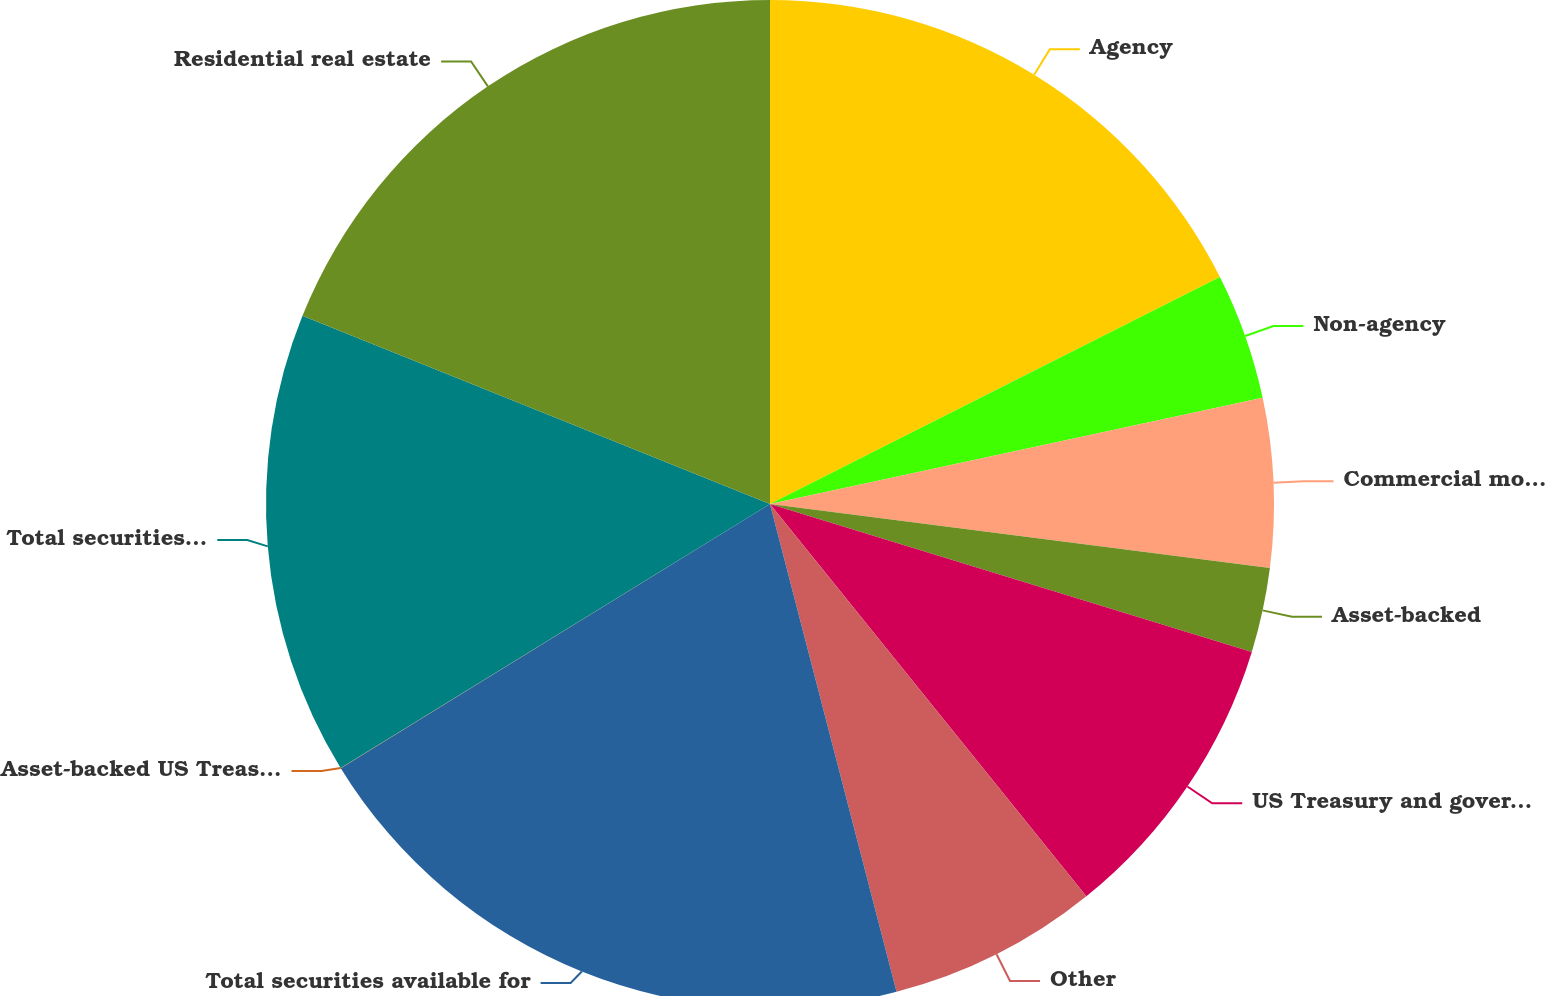Convert chart. <chart><loc_0><loc_0><loc_500><loc_500><pie_chart><fcel>Agency<fcel>Non-agency<fcel>Commercial mortgage-backed<fcel>Asset-backed<fcel>US Treasury and government<fcel>Other<fcel>Total securities available for<fcel>Asset-backed US Treasury and<fcel>Total securities held to<fcel>Residential real estate<nl><fcel>17.56%<fcel>4.06%<fcel>5.41%<fcel>2.71%<fcel>9.46%<fcel>6.76%<fcel>20.26%<fcel>0.01%<fcel>14.86%<fcel>18.91%<nl></chart> 